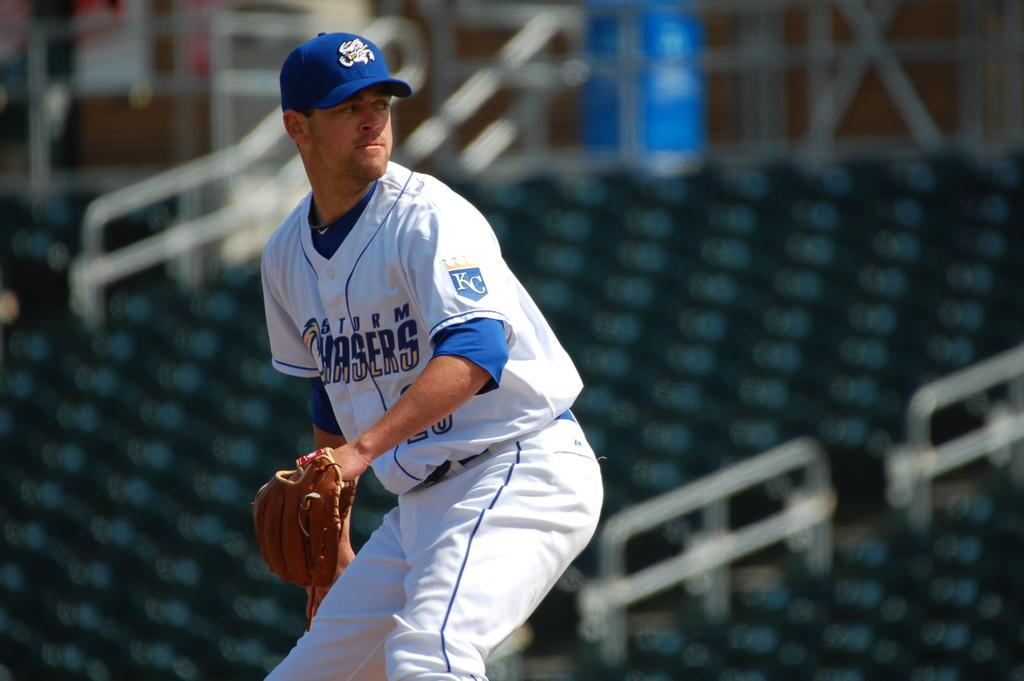<image>
Provide a brief description of the given image. the baseball player has letters K and C on his sleeve 